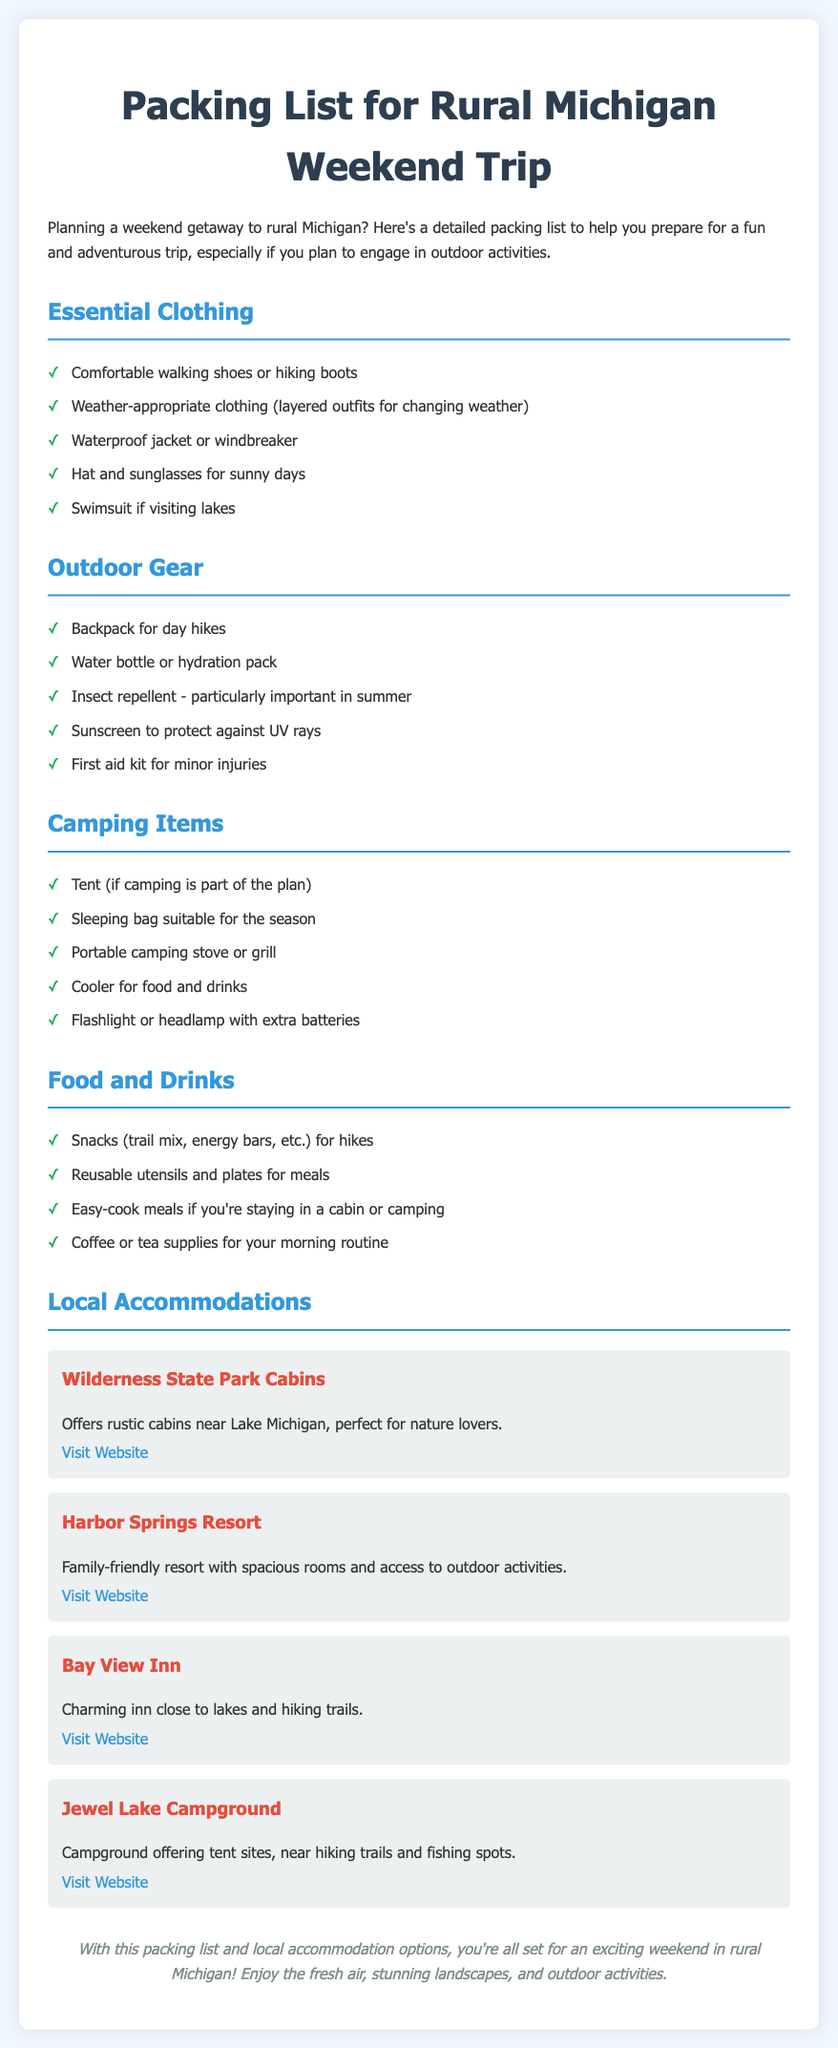What are two essential clothing items for the trip? The document lists comfortable walking shoes or hiking boots and weather-appropriate clothing as essential clothing items.
Answer: Comfortable walking shoes, weather-appropriate clothing How many local accommodation options are listed? The document lists four local accommodation options for the trip.
Answer: Four What is one item recommended for outdoor activities? The document suggests a water bottle or hydration pack as one of the items for outdoor activities.
Answer: Water bottle or hydration pack What type of stove should you bring for camping? The document recommends bringing a portable camping stove or grill for camping.
Answer: Portable camping stove or grill Which accommodation offers rustic cabins? The Wilderness State Park Cabins are mentioned as offering rustic cabins near Lake Michigan.
Answer: Wilderness State Park Cabins What type of items should be packed for food and drinks? The document indicates that snacks like trail mix or energy bars should be packed for food and drinks.
Answer: Snacks, trail mix, energy bars What protective item is emphasized for summer trips? Insect repellent is highlighted as particularly important for summer trips.
Answer: Insect repellent What should you pack for your morning routine? The document advises packing coffee or tea supplies for your morning routine.
Answer: Coffee or tea supplies 